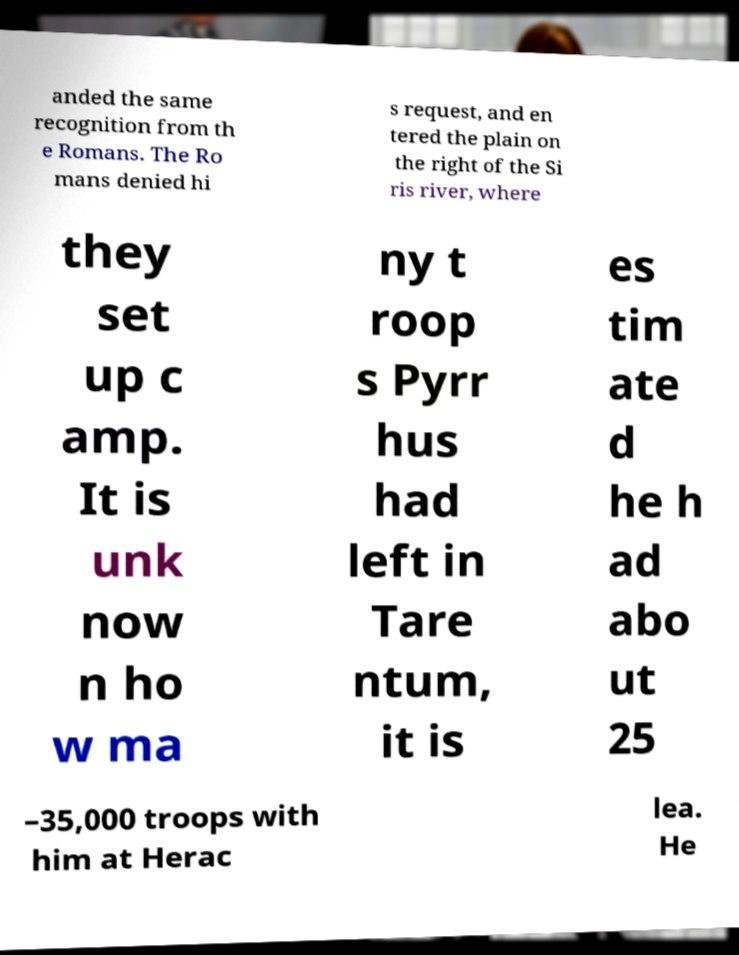Can you read and provide the text displayed in the image?This photo seems to have some interesting text. Can you extract and type it out for me? anded the same recognition from th e Romans. The Ro mans denied hi s request, and en tered the plain on the right of the Si ris river, where they set up c amp. It is unk now n ho w ma ny t roop s Pyrr hus had left in Tare ntum, it is es tim ate d he h ad abo ut 25 –35,000 troops with him at Herac lea. He 